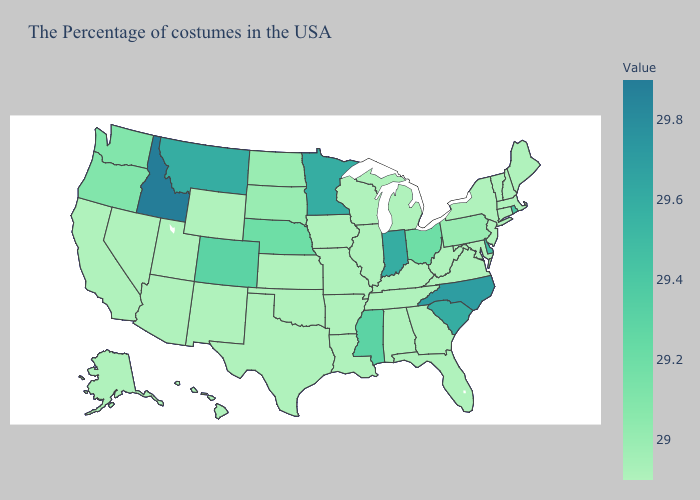Which states have the highest value in the USA?
Give a very brief answer. Idaho. Does Minnesota have the lowest value in the USA?
Short answer required. No. Among the states that border Nevada , does Idaho have the highest value?
Be succinct. Yes. Does Pennsylvania have the lowest value in the USA?
Keep it brief. No. Which states have the lowest value in the MidWest?
Give a very brief answer. Michigan, Wisconsin, Illinois, Missouri, Iowa, Kansas. Which states hav the highest value in the West?
Short answer required. Idaho. 